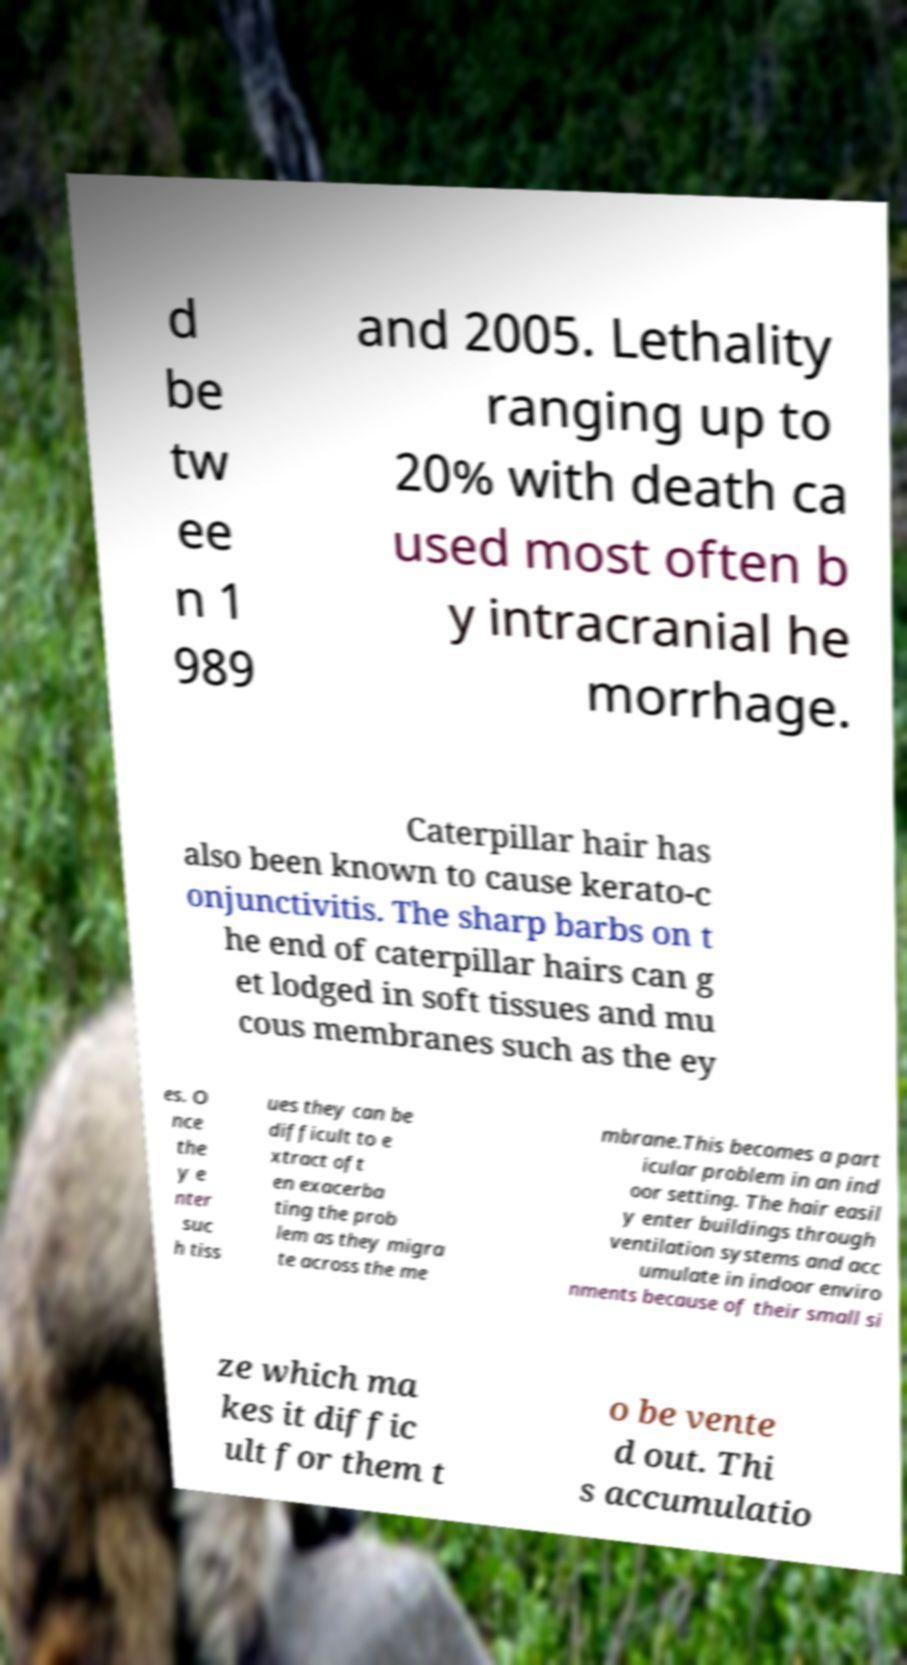I need the written content from this picture converted into text. Can you do that? d be tw ee n 1 989 and 2005. Lethality ranging up to 20% with death ca used most often b y intracranial he morrhage. Caterpillar hair has also been known to cause kerato-c onjunctivitis. The sharp barbs on t he end of caterpillar hairs can g et lodged in soft tissues and mu cous membranes such as the ey es. O nce the y e nter suc h tiss ues they can be difficult to e xtract oft en exacerba ting the prob lem as they migra te across the me mbrane.This becomes a part icular problem in an ind oor setting. The hair easil y enter buildings through ventilation systems and acc umulate in indoor enviro nments because of their small si ze which ma kes it diffic ult for them t o be vente d out. Thi s accumulatio 